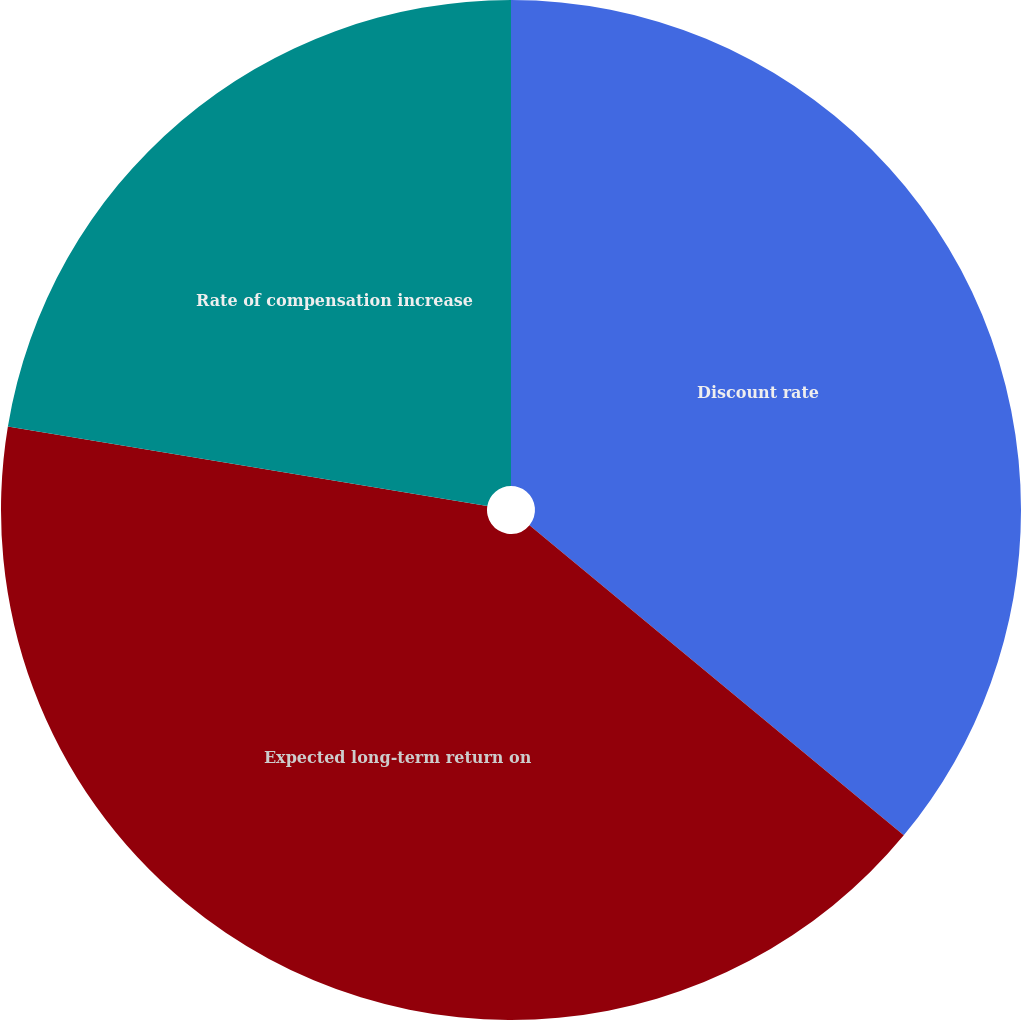Convert chart. <chart><loc_0><loc_0><loc_500><loc_500><pie_chart><fcel>Discount rate<fcel>Expected long-term return on<fcel>Rate of compensation increase<nl><fcel>36.01%<fcel>41.61%<fcel>22.38%<nl></chart> 